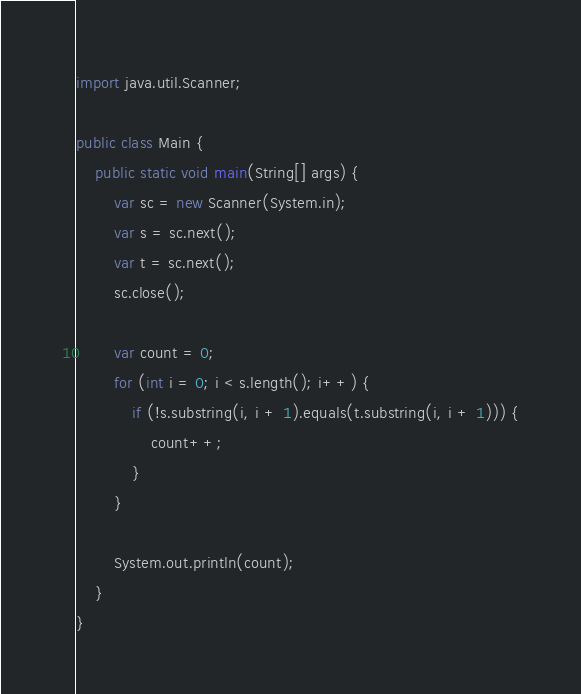<code> <loc_0><loc_0><loc_500><loc_500><_Java_>import java.util.Scanner;

public class Main {
	public static void main(String[] args) {
		var sc = new Scanner(System.in);
		var s = sc.next();
		var t = sc.next();
		sc.close();

		var count = 0;
		for (int i = 0; i < s.length(); i++) {
			if (!s.substring(i, i + 1).equals(t.substring(i, i + 1))) {
				count++;
			}
		}

		System.out.println(count);
	}
}
</code> 